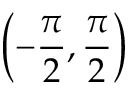<formula> <loc_0><loc_0><loc_500><loc_500>\left ( - { \frac { \pi } { 2 } } , { \frac { \pi } { 2 } } \right )</formula> 